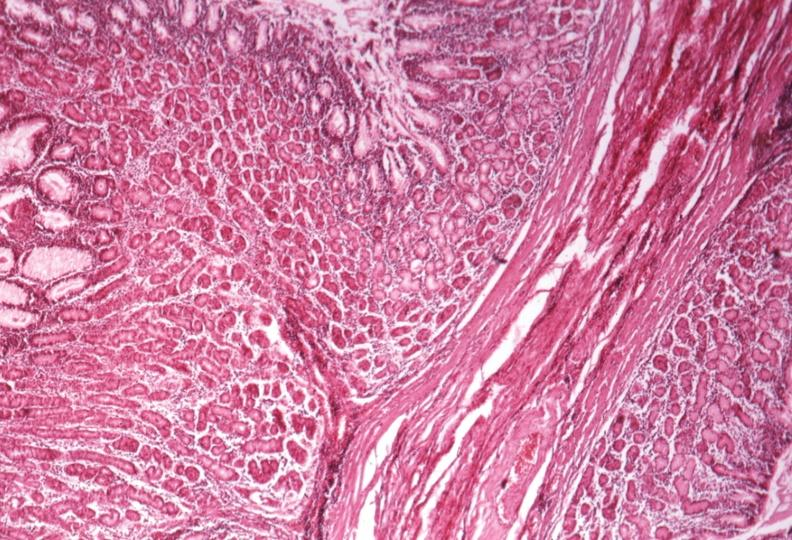s gastrointestinal present?
Answer the question using a single word or phrase. Yes 